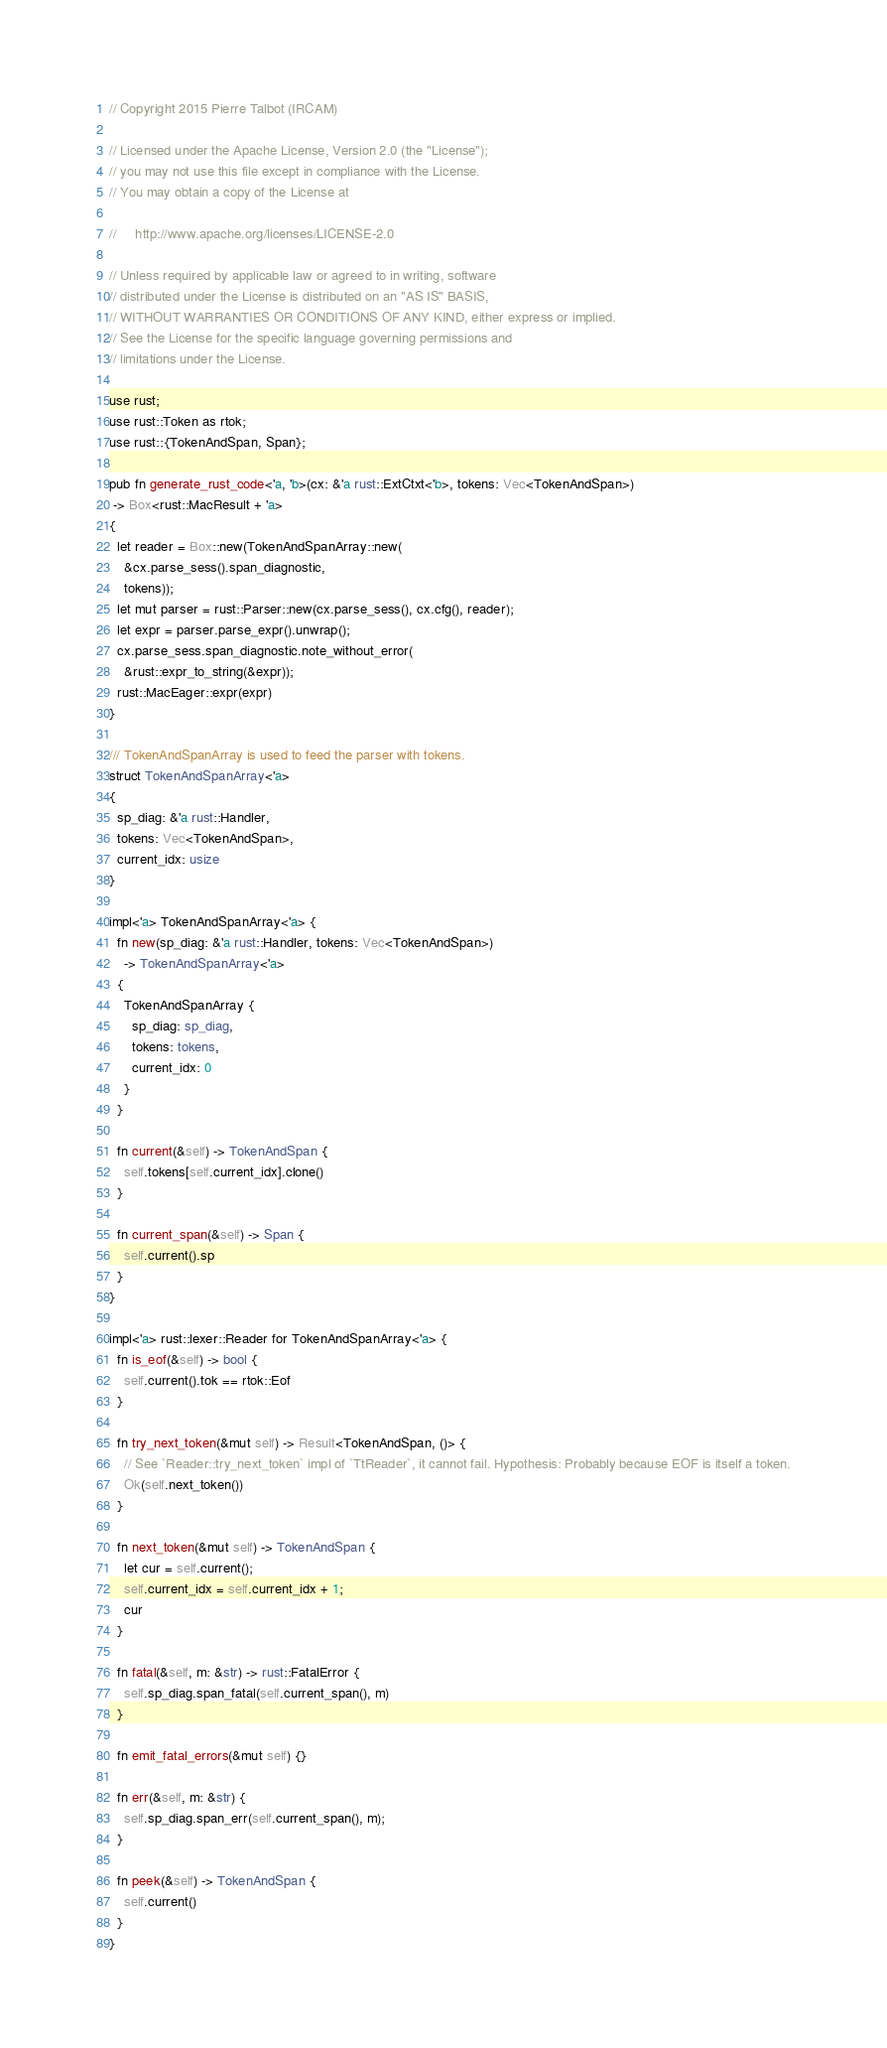Convert code to text. <code><loc_0><loc_0><loc_500><loc_500><_Rust_>// Copyright 2015 Pierre Talbot (IRCAM)

// Licensed under the Apache License, Version 2.0 (the "License");
// you may not use this file except in compliance with the License.
// You may obtain a copy of the License at

//     http://www.apache.org/licenses/LICENSE-2.0

// Unless required by applicable law or agreed to in writing, software
// distributed under the License is distributed on an "AS IS" BASIS,
// WITHOUT WARRANTIES OR CONDITIONS OF ANY KIND, either express or implied.
// See the License for the specific language governing permissions and
// limitations under the License.

use rust;
use rust::Token as rtok;
use rust::{TokenAndSpan, Span};

pub fn generate_rust_code<'a, 'b>(cx: &'a rust::ExtCtxt<'b>, tokens: Vec<TokenAndSpan>)
 -> Box<rust::MacResult + 'a>
{
  let reader = Box::new(TokenAndSpanArray::new(
    &cx.parse_sess().span_diagnostic,
    tokens));
  let mut parser = rust::Parser::new(cx.parse_sess(), cx.cfg(), reader);
  let expr = parser.parse_expr().unwrap();
  cx.parse_sess.span_diagnostic.note_without_error(
    &rust::expr_to_string(&expr));
  rust::MacEager::expr(expr)
}

/// TokenAndSpanArray is used to feed the parser with tokens.
struct TokenAndSpanArray<'a>
{
  sp_diag: &'a rust::Handler,
  tokens: Vec<TokenAndSpan>,
  current_idx: usize
}

impl<'a> TokenAndSpanArray<'a> {
  fn new(sp_diag: &'a rust::Handler, tokens: Vec<TokenAndSpan>)
    -> TokenAndSpanArray<'a>
  {
    TokenAndSpanArray {
      sp_diag: sp_diag,
      tokens: tokens,
      current_idx: 0
    }
  }

  fn current(&self) -> TokenAndSpan {
    self.tokens[self.current_idx].clone()
  }

  fn current_span(&self) -> Span {
    self.current().sp
  }
}

impl<'a> rust::lexer::Reader for TokenAndSpanArray<'a> {
  fn is_eof(&self) -> bool {
    self.current().tok == rtok::Eof
  }

  fn try_next_token(&mut self) -> Result<TokenAndSpan, ()> {
    // See `Reader::try_next_token` impl of `TtReader`, it cannot fail. Hypothesis: Probably because EOF is itself a token.
    Ok(self.next_token())
  }

  fn next_token(&mut self) -> TokenAndSpan {
    let cur = self.current();
    self.current_idx = self.current_idx + 1;
    cur
  }

  fn fatal(&self, m: &str) -> rust::FatalError {
    self.sp_diag.span_fatal(self.current_span(), m)
  }

  fn emit_fatal_errors(&mut self) {}

  fn err(&self, m: &str) {
    self.sp_diag.span_err(self.current_span(), m);
  }

  fn peek(&self) -> TokenAndSpan {
    self.current()
  }
}
</code> 